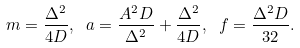Convert formula to latex. <formula><loc_0><loc_0><loc_500><loc_500>m = \frac { \Delta ^ { 2 } } { 4 D } , \ a = \frac { A ^ { 2 } D } { \Delta ^ { 2 } } + \frac { \Delta ^ { 2 } } { 4 D } , \ f = \frac { \Delta ^ { 2 } D } { 3 2 } .</formula> 